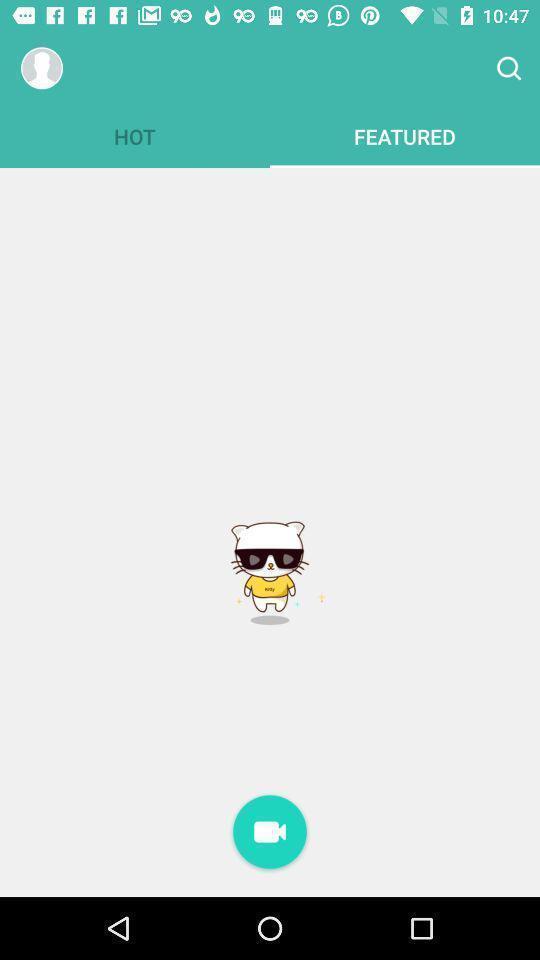Tell me about the visual elements in this screen capture. Page showing the about profile with video call options. 